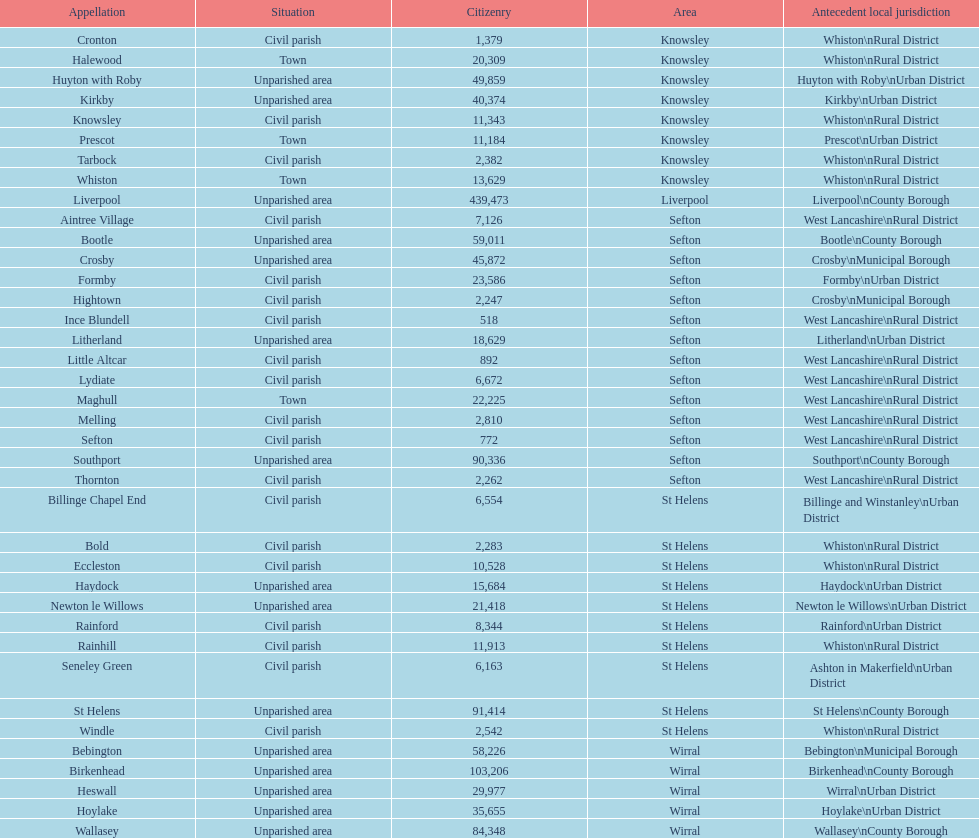How many civil parishes have population counts of at least 10,000? 4. Could you help me parse every detail presented in this table? {'header': ['Appellation', 'Situation', 'Citizenry', 'Area', 'Antecedent local jurisdiction'], 'rows': [['Cronton', 'Civil parish', '1,379', 'Knowsley', 'Whiston\\nRural District'], ['Halewood', 'Town', '20,309', 'Knowsley', 'Whiston\\nRural District'], ['Huyton with Roby', 'Unparished area', '49,859', 'Knowsley', 'Huyton with Roby\\nUrban District'], ['Kirkby', 'Unparished area', '40,374', 'Knowsley', 'Kirkby\\nUrban District'], ['Knowsley', 'Civil parish', '11,343', 'Knowsley', 'Whiston\\nRural District'], ['Prescot', 'Town', '11,184', 'Knowsley', 'Prescot\\nUrban District'], ['Tarbock', 'Civil parish', '2,382', 'Knowsley', 'Whiston\\nRural District'], ['Whiston', 'Town', '13,629', 'Knowsley', 'Whiston\\nRural District'], ['Liverpool', 'Unparished area', '439,473', 'Liverpool', 'Liverpool\\nCounty Borough'], ['Aintree Village', 'Civil parish', '7,126', 'Sefton', 'West Lancashire\\nRural District'], ['Bootle', 'Unparished area', '59,011', 'Sefton', 'Bootle\\nCounty Borough'], ['Crosby', 'Unparished area', '45,872', 'Sefton', 'Crosby\\nMunicipal Borough'], ['Formby', 'Civil parish', '23,586', 'Sefton', 'Formby\\nUrban District'], ['Hightown', 'Civil parish', '2,247', 'Sefton', 'Crosby\\nMunicipal Borough'], ['Ince Blundell', 'Civil parish', '518', 'Sefton', 'West Lancashire\\nRural District'], ['Litherland', 'Unparished area', '18,629', 'Sefton', 'Litherland\\nUrban District'], ['Little Altcar', 'Civil parish', '892', 'Sefton', 'West Lancashire\\nRural District'], ['Lydiate', 'Civil parish', '6,672', 'Sefton', 'West Lancashire\\nRural District'], ['Maghull', 'Town', '22,225', 'Sefton', 'West Lancashire\\nRural District'], ['Melling', 'Civil parish', '2,810', 'Sefton', 'West Lancashire\\nRural District'], ['Sefton', 'Civil parish', '772', 'Sefton', 'West Lancashire\\nRural District'], ['Southport', 'Unparished area', '90,336', 'Sefton', 'Southport\\nCounty Borough'], ['Thornton', 'Civil parish', '2,262', 'Sefton', 'West Lancashire\\nRural District'], ['Billinge Chapel End', 'Civil parish', '6,554', 'St Helens', 'Billinge and Winstanley\\nUrban District'], ['Bold', 'Civil parish', '2,283', 'St Helens', 'Whiston\\nRural District'], ['Eccleston', 'Civil parish', '10,528', 'St Helens', 'Whiston\\nRural District'], ['Haydock', 'Unparished area', '15,684', 'St Helens', 'Haydock\\nUrban District'], ['Newton le Willows', 'Unparished area', '21,418', 'St Helens', 'Newton le Willows\\nUrban District'], ['Rainford', 'Civil parish', '8,344', 'St Helens', 'Rainford\\nUrban District'], ['Rainhill', 'Civil parish', '11,913', 'St Helens', 'Whiston\\nRural District'], ['Seneley Green', 'Civil parish', '6,163', 'St Helens', 'Ashton in Makerfield\\nUrban District'], ['St Helens', 'Unparished area', '91,414', 'St Helens', 'St Helens\\nCounty Borough'], ['Windle', 'Civil parish', '2,542', 'St Helens', 'Whiston\\nRural District'], ['Bebington', 'Unparished area', '58,226', 'Wirral', 'Bebington\\nMunicipal Borough'], ['Birkenhead', 'Unparished area', '103,206', 'Wirral', 'Birkenhead\\nCounty Borough'], ['Heswall', 'Unparished area', '29,977', 'Wirral', 'Wirral\\nUrban District'], ['Hoylake', 'Unparished area', '35,655', 'Wirral', 'Hoylake\\nUrban District'], ['Wallasey', 'Unparished area', '84,348', 'Wirral', 'Wallasey\\nCounty Borough']]} 